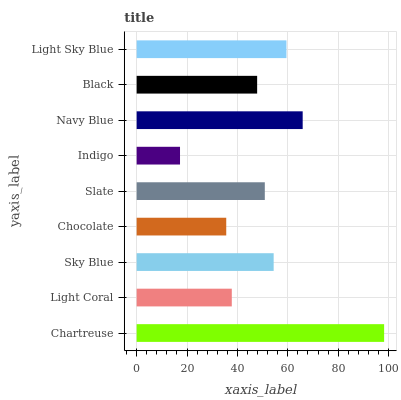Is Indigo the minimum?
Answer yes or no. Yes. Is Chartreuse the maximum?
Answer yes or no. Yes. Is Light Coral the minimum?
Answer yes or no. No. Is Light Coral the maximum?
Answer yes or no. No. Is Chartreuse greater than Light Coral?
Answer yes or no. Yes. Is Light Coral less than Chartreuse?
Answer yes or no. Yes. Is Light Coral greater than Chartreuse?
Answer yes or no. No. Is Chartreuse less than Light Coral?
Answer yes or no. No. Is Slate the high median?
Answer yes or no. Yes. Is Slate the low median?
Answer yes or no. Yes. Is Chocolate the high median?
Answer yes or no. No. Is Chartreuse the low median?
Answer yes or no. No. 